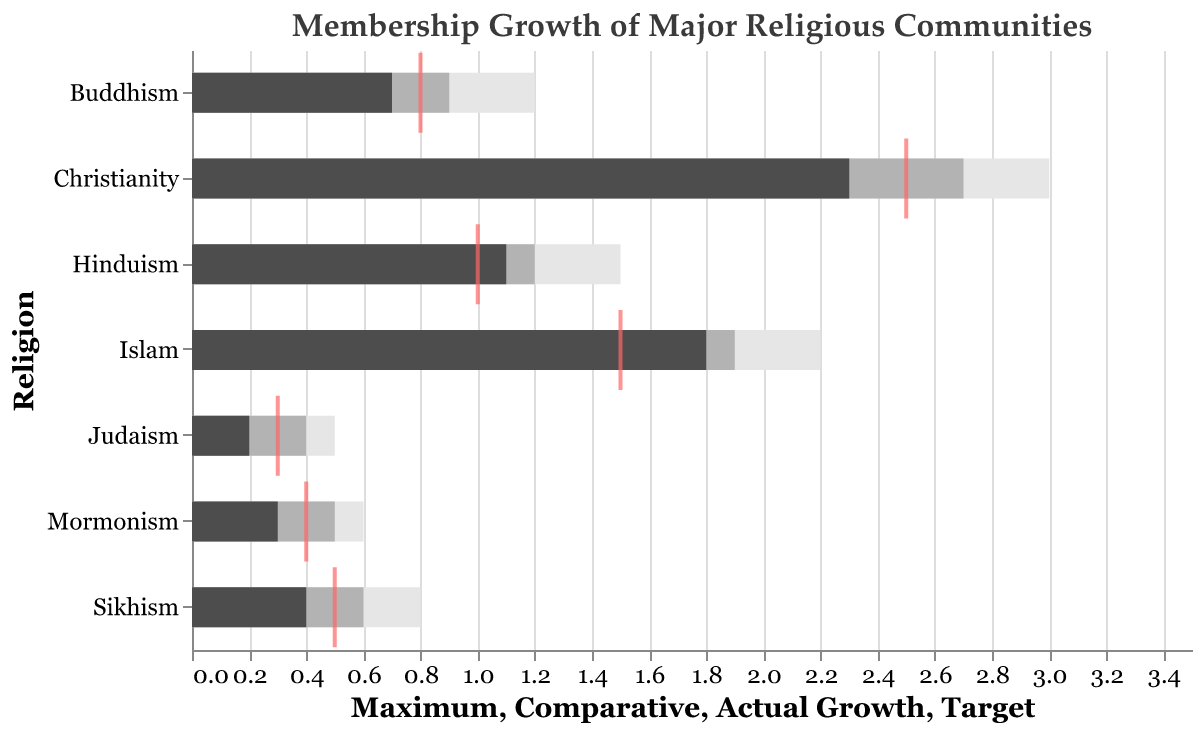What is the title of the figure? The title is typically located at the top of the figure and provides a summary of what the figure represents. In this case, the title is "Membership Growth of Major Religious Communities".
Answer: Membership Growth of Major Religious Communities Which religious community has the highest actual growth rate? To determine which group has the highest actual growth rate, compare the "Actual Growth" values for all the religions listed. Christianity has the highest value at 2.3%.
Answer: Christianity How does the actual growth rate of Islam compare to its target growth rate? Look at the "Actual Growth" and "Target" for Islam. The actual growth rate of Islam is 1.8%, and the target growth rate is 1.5%. Since 1.8% is greater than 1.5%, it has exceeded its target.
Answer: Islam's actual growth rate exceeds its target growth rate Which religious communities did not meet their target growth rates? Compare the "Actual Growth" rates to the "Target" growth rates for each religion. Buddhism (0.7% actual vs. 0.8% target), Sikhism (0.4% actual vs. 0.5% target), Judaism (0.2% actual vs. 0.3% target), and Mormonism (0.3% actual vs. 0.4% target) did not meet their targets.
Answer: Buddhism, Sikhism, Judaism, and Mormonism What is the difference between the maximum growth rate and the actual growth rate for Hinduism? Subtract the "Actual Growth" rate from the "Maximum" growth rate for Hinduism. The calculation is 1.5 (Maximum) - 1.1 (Actual Growth) = 0.4%.
Answer: 0.4% What color is used to represent the comparative growth rate? In the visual diagram, comparative growth rates are represented using a color. From the description, the comparative growth rate is visualized with the color gray (#b3b3b3).
Answer: Gray Which religious community's actual growth rate is closest to its target growth rate? Calculate the difference between the "Actual Growth" and the "Target" rates for each religion and find the smallest difference. For Christianity, the difference is 0.2 (2.3 - 2.5); for Islam, it is 0.3 (1.8 - 1.5); for Hinduism, it is 0.1 (1.1 - 1.0); for Buddhism, it is 0.1 (0.7 - 0.8); for Sikhism, it is 0.1 (0.4 - 0.5); for Judaism, it is 0.1 (0.2 - 0.3); for Mormonism, it is 0.1 (0.3 - 0.4). Hinduism, Buddhism, Sikhism, Judaism, and Mormonism all have the smallest difference of 0.1.
Answer: Hinduism, Buddhism, Sikhism, Judaism, and Mormonism Which religious community has the lowest actual growth rate and how does it compare to its maximum growth rate? To identify the community with the lowest actual growth rate, locate the smallest value in the "Actual Growth" column, which is Judaism at 0.2%. The maximum growth rate for Judaism is 0.5%.
Answer: Judaism has the lowest actual growth rate of 0.2%, and its maximum growth rate is 0.5% How many religious communities have an actual growth rate higher than their target growth rate? Compare the "Actual Growth" rate to the "Target" growth rate for each religion. Christianity (2.3 > 2.5), Islam (1.8 > 1.5), and Hinduism (1.1 > 1.0) all have higher actual growth rates than their target growth rates. That’s a total of 3 communities.
Answer: 3 